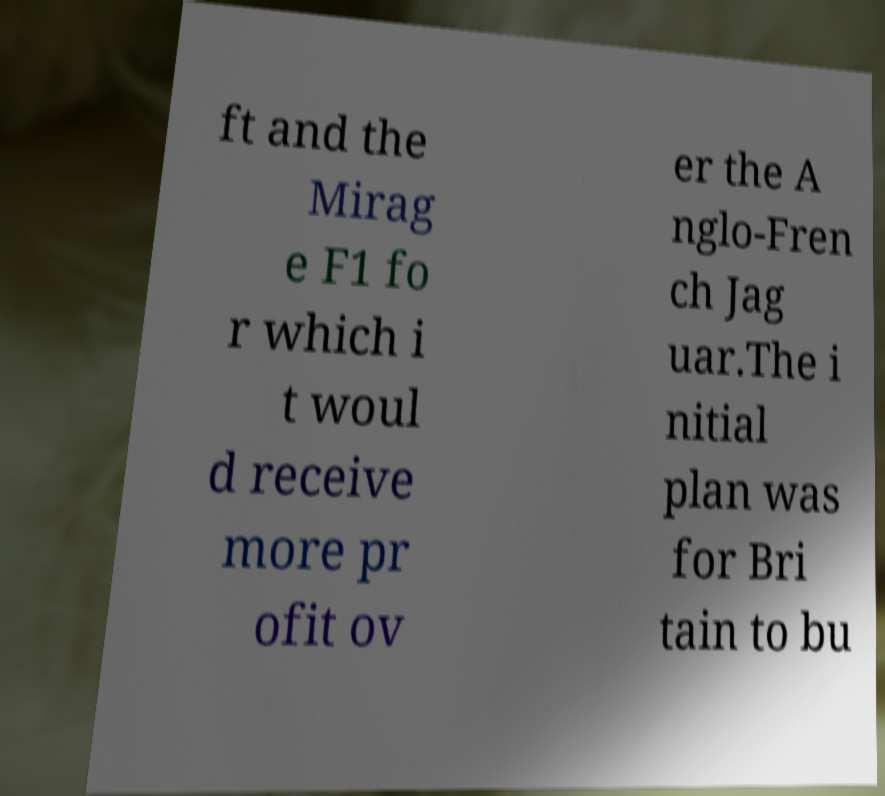Could you assist in decoding the text presented in this image and type it out clearly? ft and the Mirag e F1 fo r which i t woul d receive more pr ofit ov er the A nglo-Fren ch Jag uar.The i nitial plan was for Bri tain to bu 